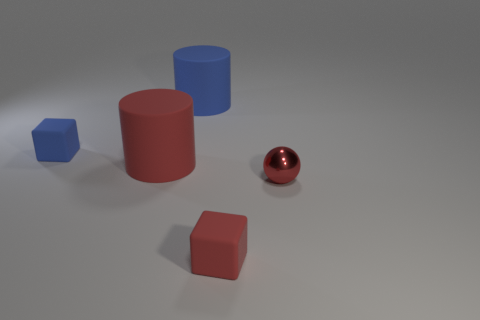Add 2 tiny red balls. How many objects exist? 7 Subtract all balls. How many objects are left? 4 Add 4 red metal spheres. How many red metal spheres exist? 5 Subtract 0 brown blocks. How many objects are left? 5 Subtract all red cylinders. Subtract all cyan shiny objects. How many objects are left? 4 Add 1 big objects. How many big objects are left? 3 